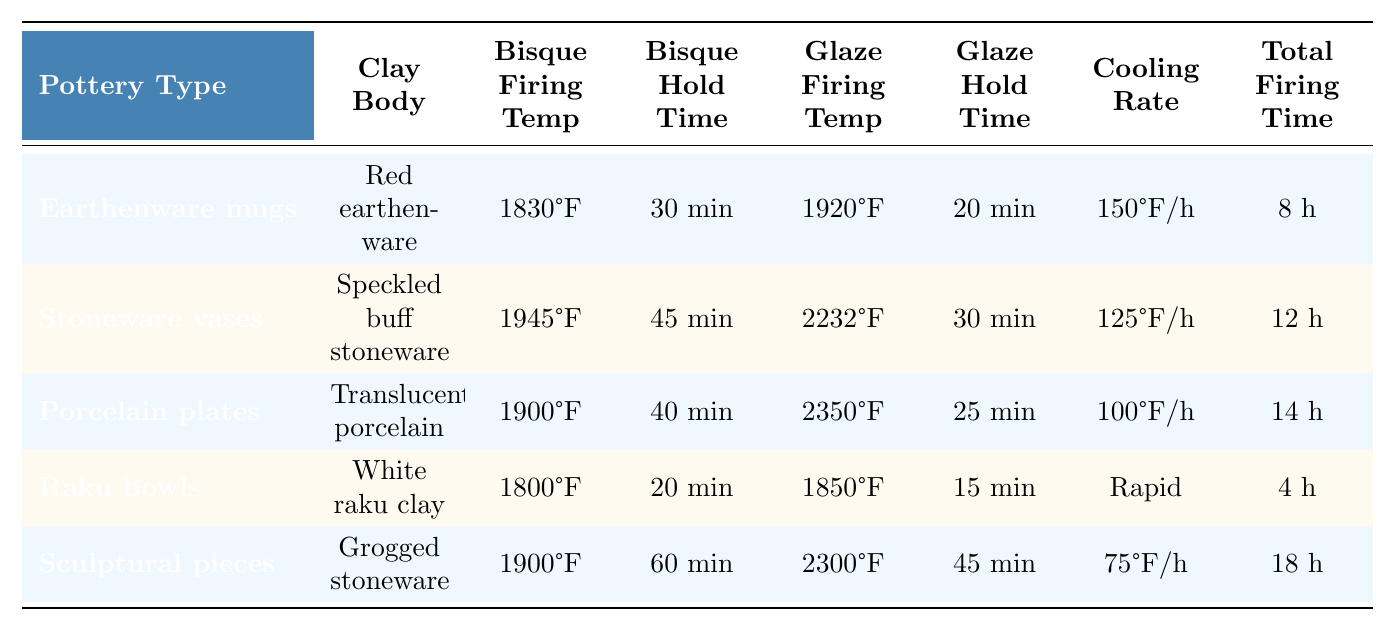What is the bisque firing temperature for earthenware mugs? The table lists the bisque firing temperature for earthenware mugs as 1830°F in the corresponding row.
Answer: 1830°F How long is the glaze hold time for porcelain plates? According to the table, the glaze hold time for porcelain plates is 25 minutes, as found in their specific entry.
Answer: 25 minutes Which pottery type has the highest glaze firing temperature? By comparing the glaze firing temperatures listed for each pottery type, it is clear that porcelain plates have the highest at 2350°F.
Answer: Porcelain plates What is the total firing time for Raku bowls? The total firing time for Raku bowls is found in the table under the specific entry for that pottery type, which is 4 hours.
Answer: 4 hours Is the cooling rate for sculptural pieces 75°F per hour? The table specifies that the cooling rate for sculptural pieces is 75°F per hour, confirming the statement as true.
Answer: Yes How much longer is the total firing time for sculptural pieces compared to Raku bowls? The total firing time for sculptural pieces is 18 hours, and for Raku bowls, it is 4 hours. To find the difference, subtract 4 from 18, which equals 14 hours.
Answer: 14 hours What is the average bisque firing temperature for all pottery types listed? Adding the bisque firing temperatures: 1830 + 1945 + 1900 + 1800 + 1900 = 10375°F, then dividing by 5 (the number of types) gives an average of 2075°F.
Answer: 2075°F Which pottery type has the longest bisque hold time and what is that time? By examining the bisque hold times in the table, it is clear that sculptural pieces have the longest hold time at 60 minutes.
Answer: Sculptural pieces, 60 minutes What is the difference in cooling rates between earthenware mugs and Raku bowls? The cooling rate for earthenware mugs is 150°F per hour, while Raku bowls have a rapid cooling rate, which we will consider as significantly faster. Therefore, the difference is not quantifiable in numeric terms, but Raku bowls cool faster.
Answer: Raku bowls cool faster If I compare the glaze firing times of stoneware vases and sculptural pieces, which is longer and by how much? The glaze firing time for stoneware vases is 30 minutes, and for sculptural pieces, it is 45 minutes. Subtracting gives 45 - 30 = 15 minutes, indicating sculptural pieces take longer.
Answer: Sculptural pieces, 15 minutes longer 